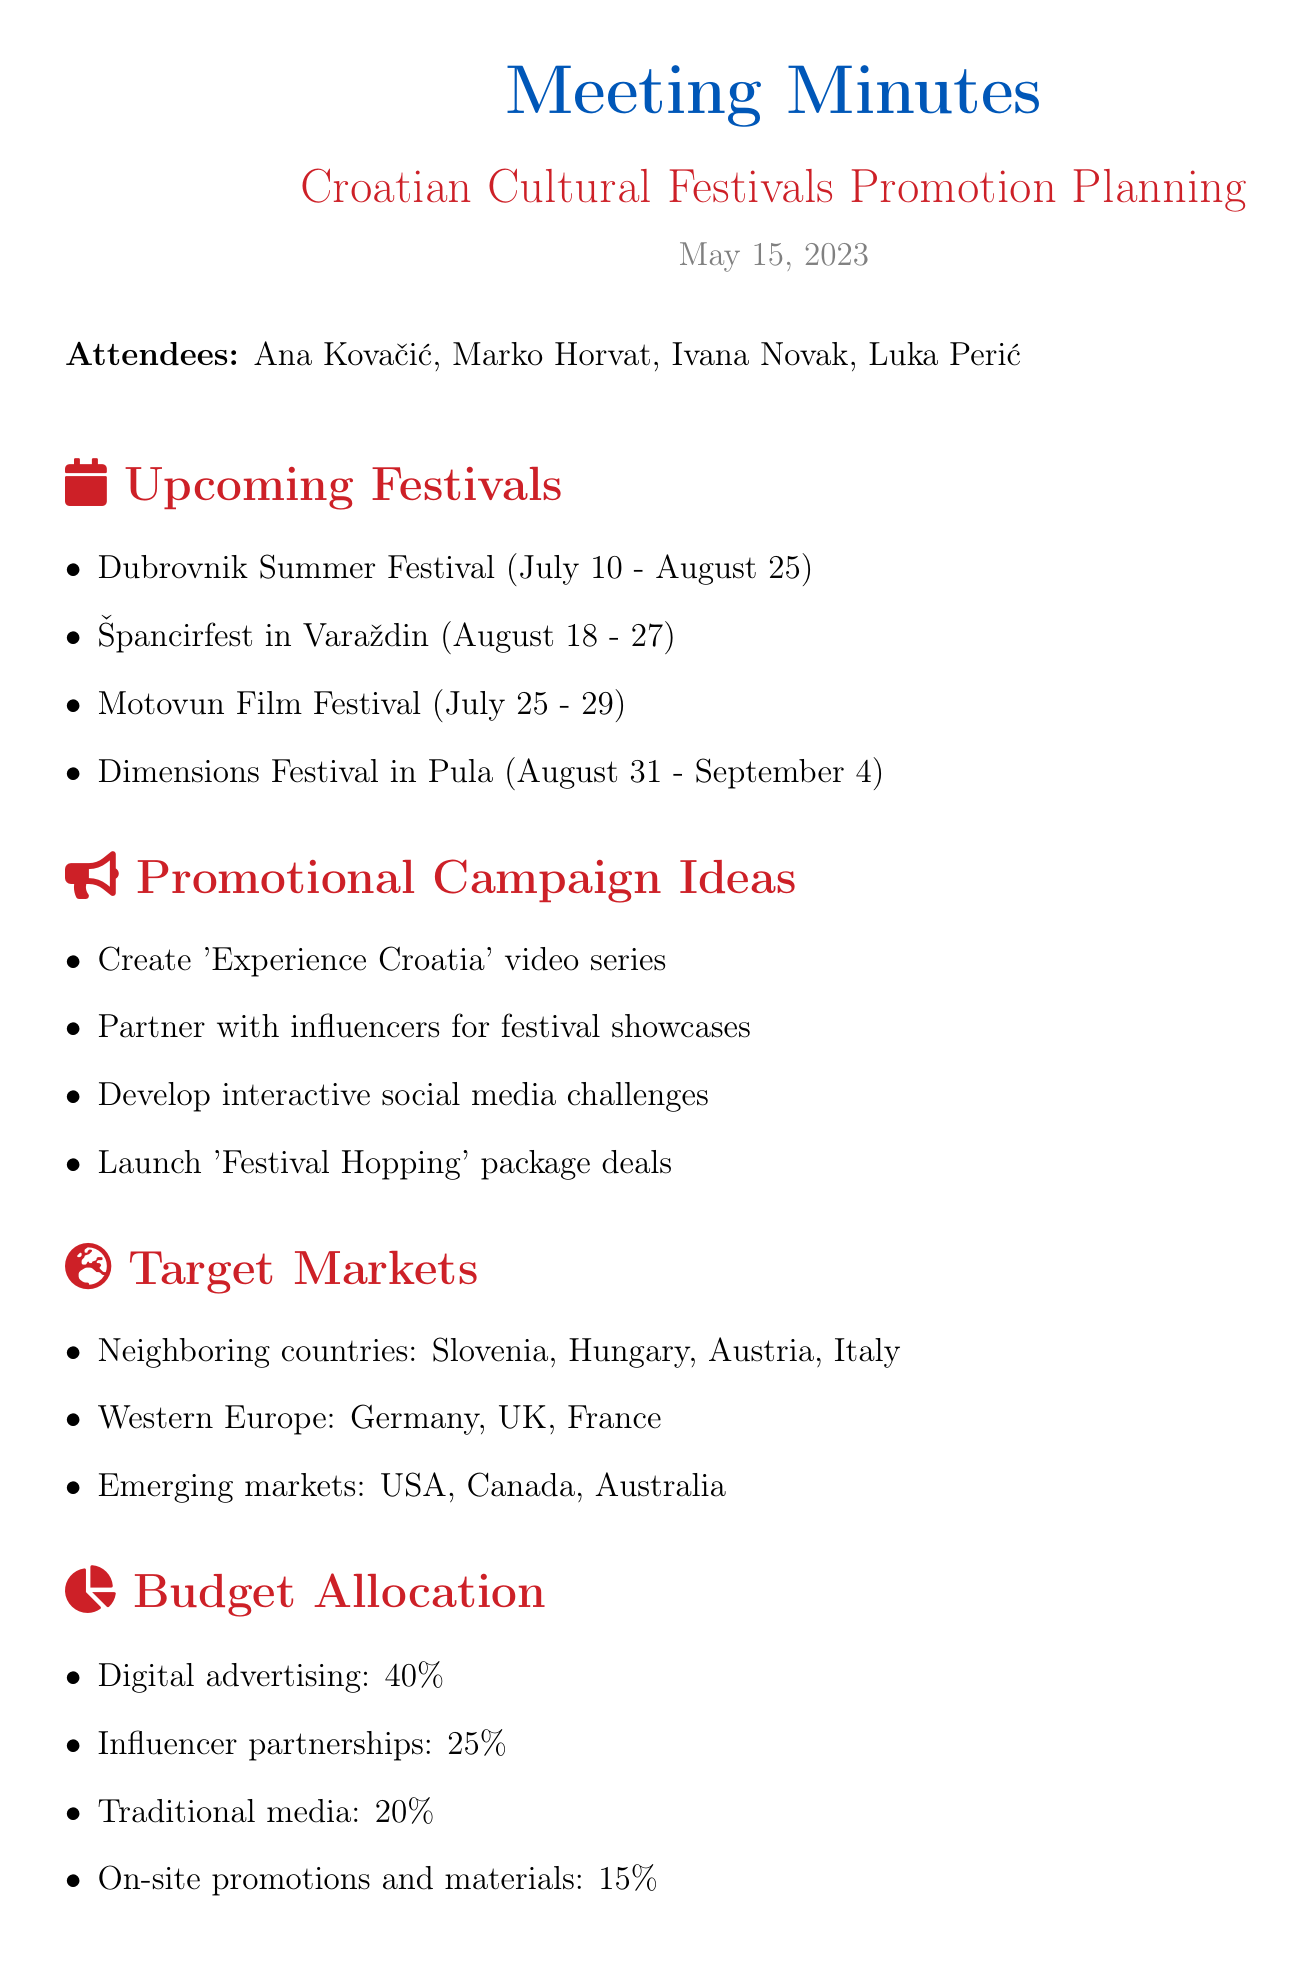What is the title of the meeting? The title of the meeting is stated at the beginning of the document.
Answer: Croatian Cultural Festivals Promotion Planning What are the dates for the Dubrovnik Summer Festival? The specific dates for the Dubrovnik Summer Festival are listed in the overview section.
Answer: July 10 - August 25 How many new newsletter subscriptions are the KPIs aiming to generate? This information can be found in the Key Performance Indicators section detailing the goals of the campaign.
Answer: 5,000 Which country is included in the target markets for expanding reach? The target markets section lists several countries, including those of focus for expansion.
Answer: Germany What percentage of the budget is allocated to digital advertising? The budget allocation section provides a breakdown of funding for different promotional strategies.
Answer: 40% What action item is due by June 1? This is listed in the action items section specifying deadlines for promotional tasks.
Answer: Finalize promotional materials How many festivals are overviewed in the document? Counting the festivals in the Upcoming Festivals section will provide the total number.
Answer: Four 